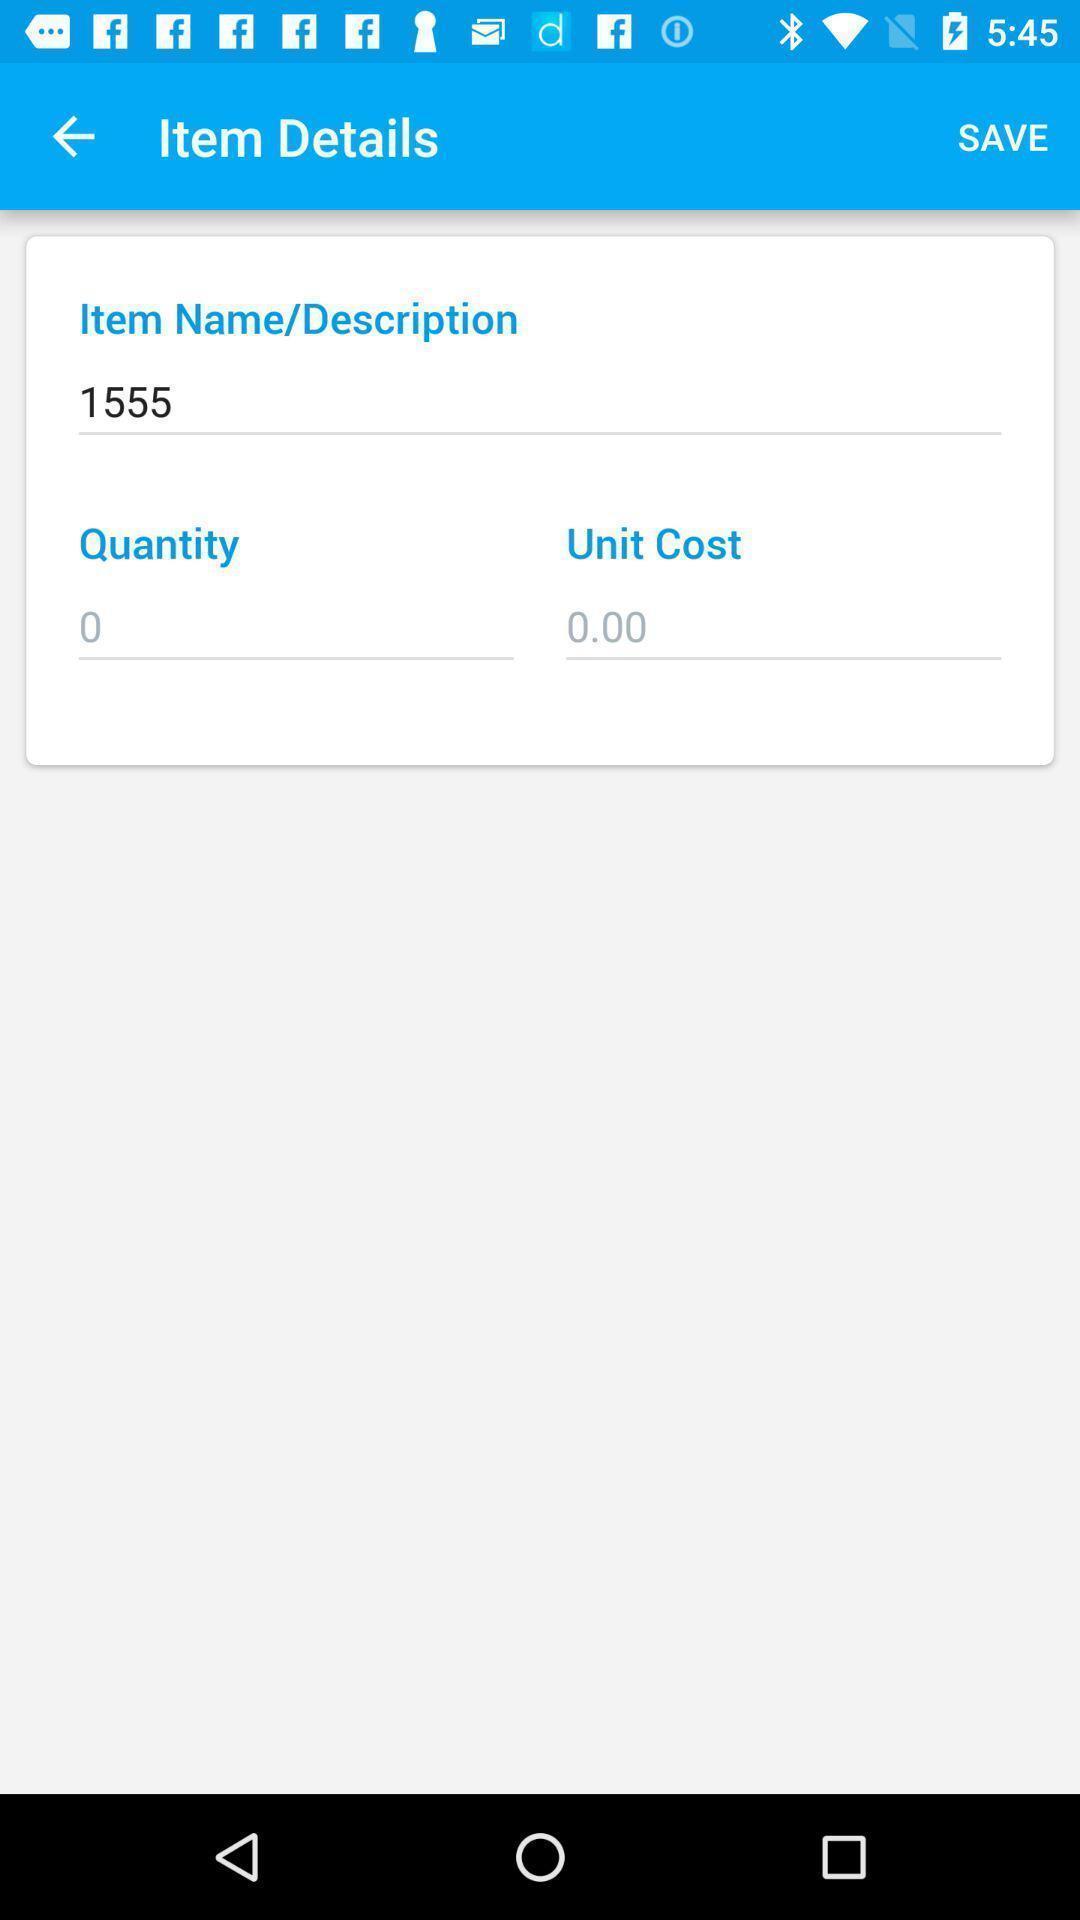Provide a textual representation of this image. Page displays item details in app. 